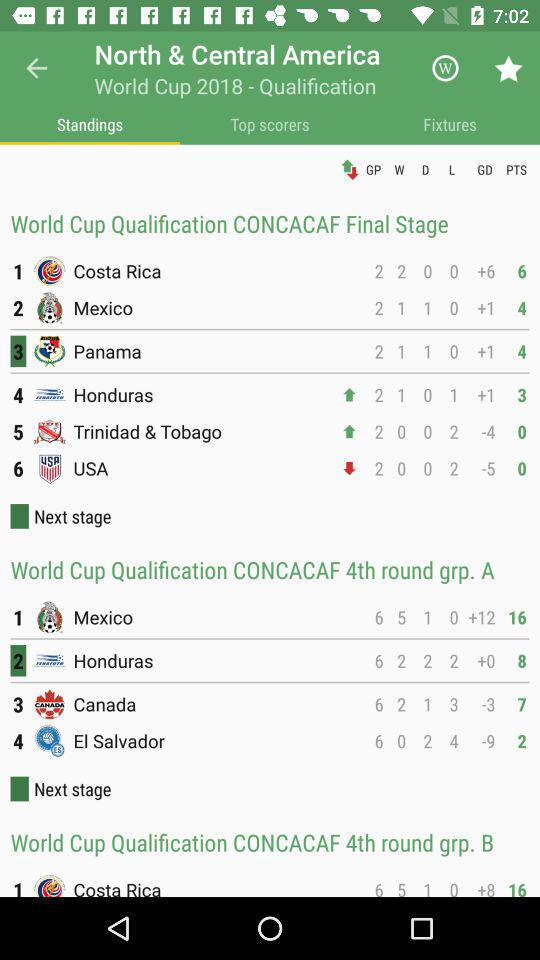What's the number of GP by the USA in the "CONCACAF Final Stage"? The number of GP by the USA in the "CONCACAF Final Stage" is 2. 